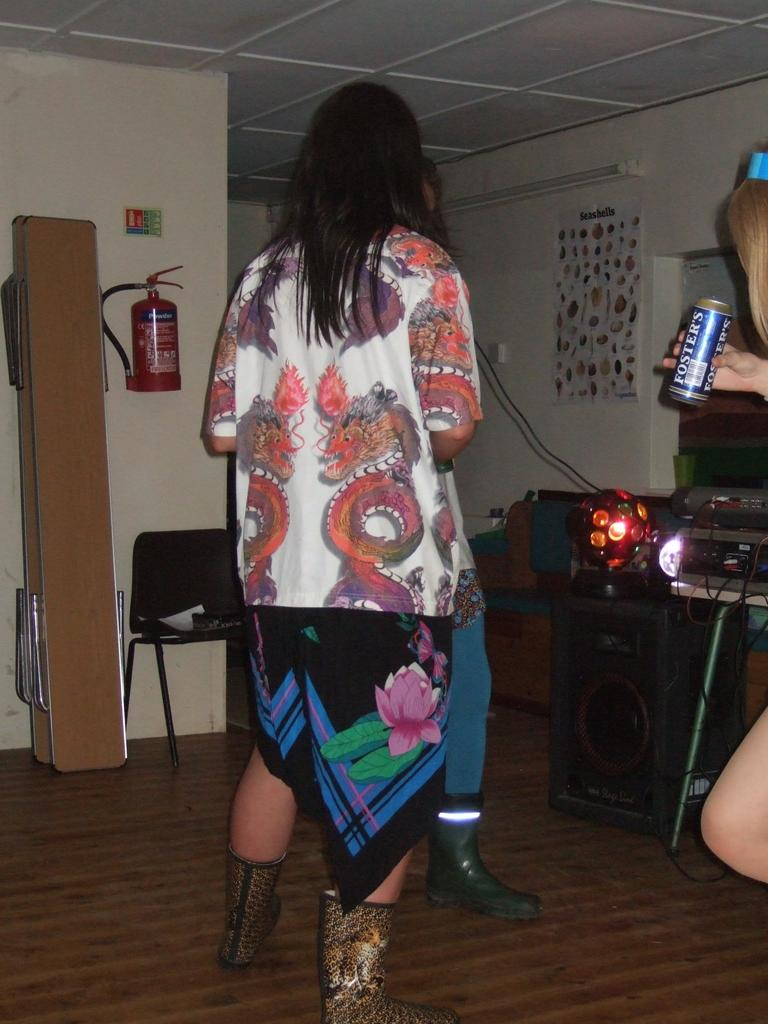Who is the main subject in the image? There is a woman in the image. What is the woman wearing? The woman is wearing designer clothes. Where is the woman positioned in the image? The woman is standing in the center of the image. Who else is present in the image? There is a girl in the image. What is the girl holding? The girl is holding a tin. What is the name of the tin? The tin is named FOSTERS. What type of noise can be heard coming from the dogs in the image? There are no dogs present in the image, so no noise can be heard from them. What is the time of day depicted in the image? The provided facts do not mention the time of day, so it cannot be determined from the image. 